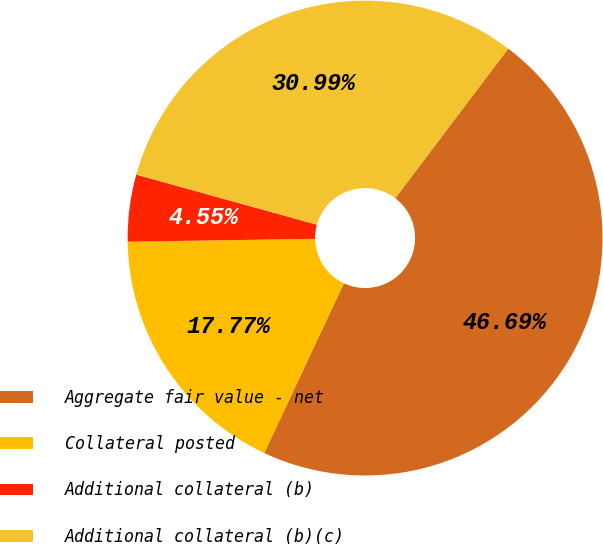<chart> <loc_0><loc_0><loc_500><loc_500><pie_chart><fcel>Aggregate fair value - net<fcel>Collateral posted<fcel>Additional collateral (b)<fcel>Additional collateral (b)(c)<nl><fcel>46.69%<fcel>17.77%<fcel>4.55%<fcel>30.99%<nl></chart> 